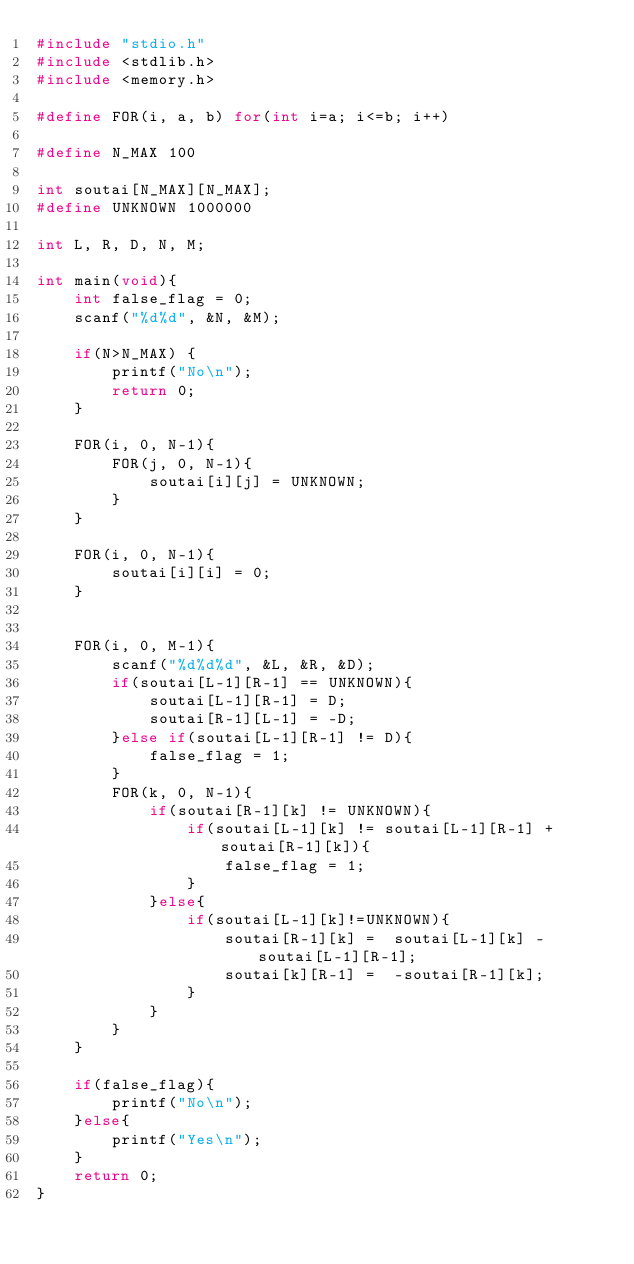Convert code to text. <code><loc_0><loc_0><loc_500><loc_500><_C++_>#include "stdio.h"
#include <stdlib.h>
#include <memory.h>

#define FOR(i, a, b) for(int i=a; i<=b; i++)

#define N_MAX 100

int soutai[N_MAX][N_MAX];
#define UNKNOWN 1000000

int L, R, D, N, M;

int main(void){
	int false_flag = 0;
	scanf("%d%d", &N, &M);

	if(N>N_MAX) {
		printf("No\n");
		return 0;
	}

	FOR(i, 0, N-1){
		FOR(j, 0, N-1){
			soutai[i][j] = UNKNOWN;
		}
	}

	FOR(i, 0, N-1){
		soutai[i][i] = 0;
	}


	FOR(i, 0, M-1){
		scanf("%d%d%d", &L, &R, &D);
		if(soutai[L-1][R-1] == UNKNOWN){
			soutai[L-1][R-1] = D;
			soutai[R-1][L-1] = -D;
		}else if(soutai[L-1][R-1] != D){
			false_flag = 1;
		}
		FOR(k, 0, N-1){
			if(soutai[R-1][k] != UNKNOWN){
				if(soutai[L-1][k] != soutai[L-1][R-1] + soutai[R-1][k]){
					false_flag = 1;
				}
			}else{
				if(soutai[L-1][k]!=UNKNOWN){
					soutai[R-1][k] =  soutai[L-1][k] - soutai[L-1][R-1];
					soutai[k][R-1] =  -soutai[R-1][k];
				}
			}
		}
	}

	if(false_flag){
		printf("No\n");
	}else{
		printf("Yes\n");
	}
	return 0;
}</code> 